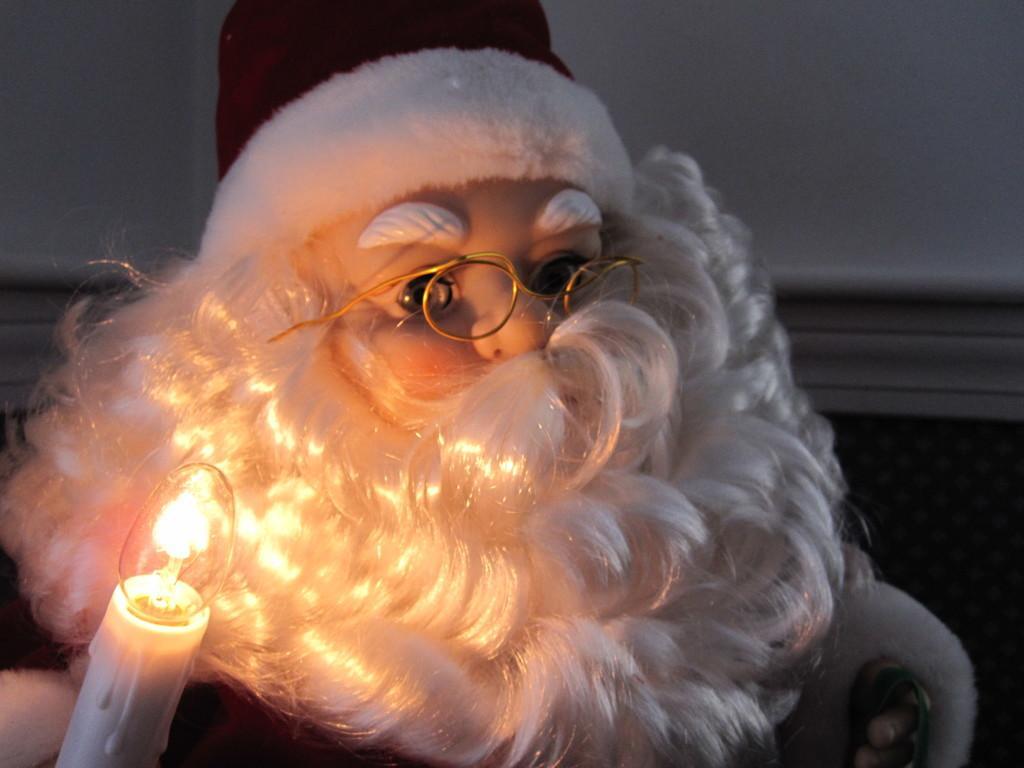Please provide a concise description of this image. In the image we can see toy Santa, wearing clothes, cap and spectacles. Here we can see candle and the wall. 